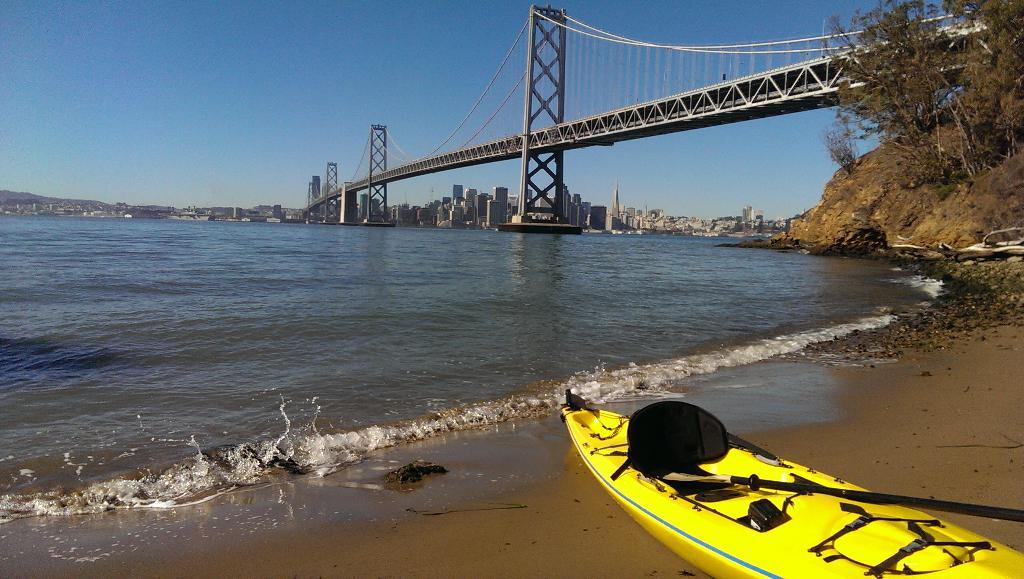What is the main subject of the image? The main subject of the image is a boat. What can be seen in the water surrounding the boat? There is water visible in the image. What type of vegetation is on the right side of the image? There are trees on the right side of the image. What structure is present in the image? There is a bridge in the image. What is visible in the background of the image? There are buildings and the sky visible in the background of the image. Can you tell me how many pieces of cheese are on the beds in the image? There are no beds or cheese present in the image; it features a boat, water, trees, a bridge, buildings, and the sky. 